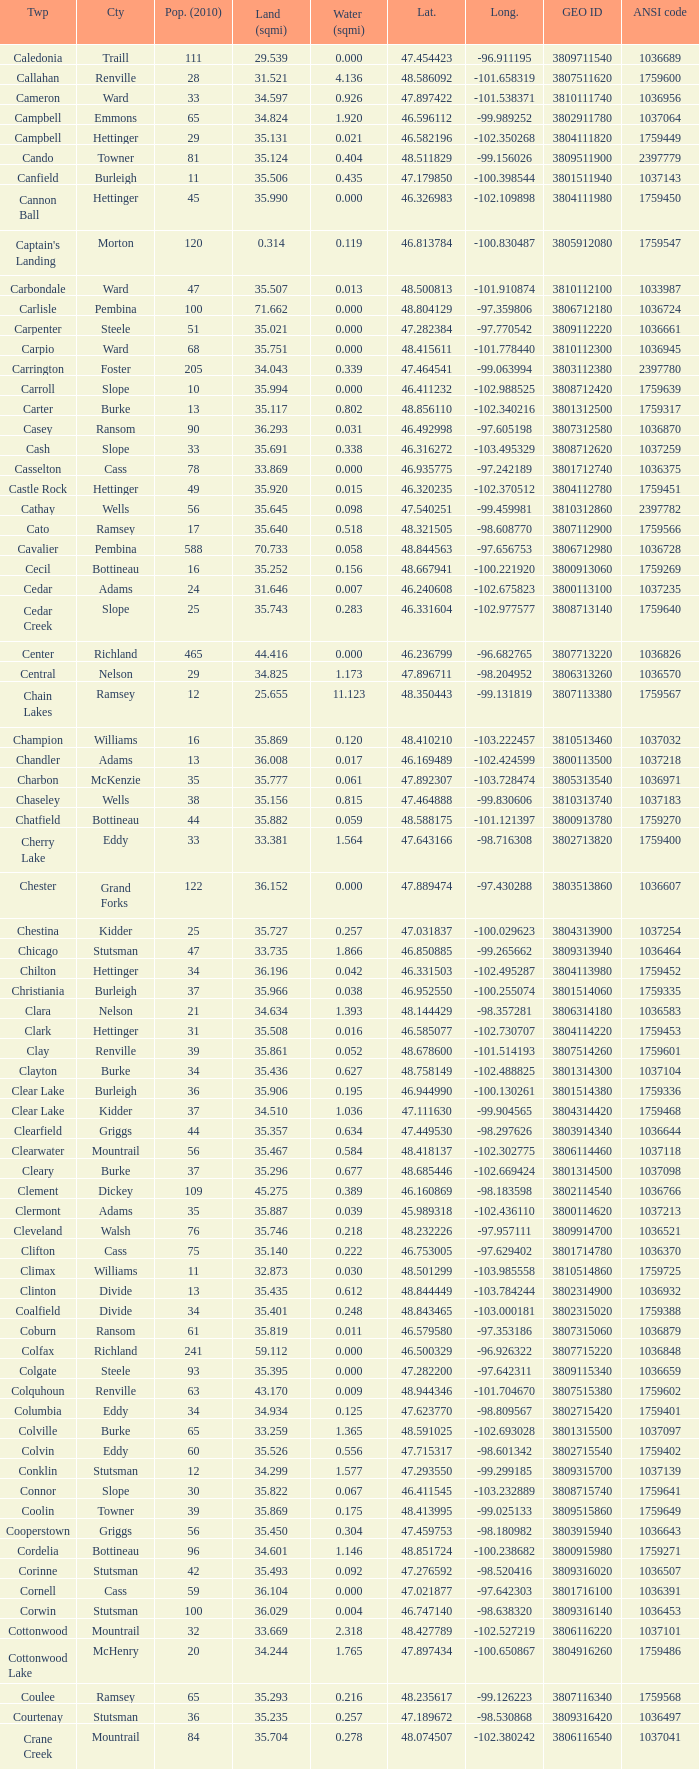What was the township with a geo ID of 3807116660? Creel. 